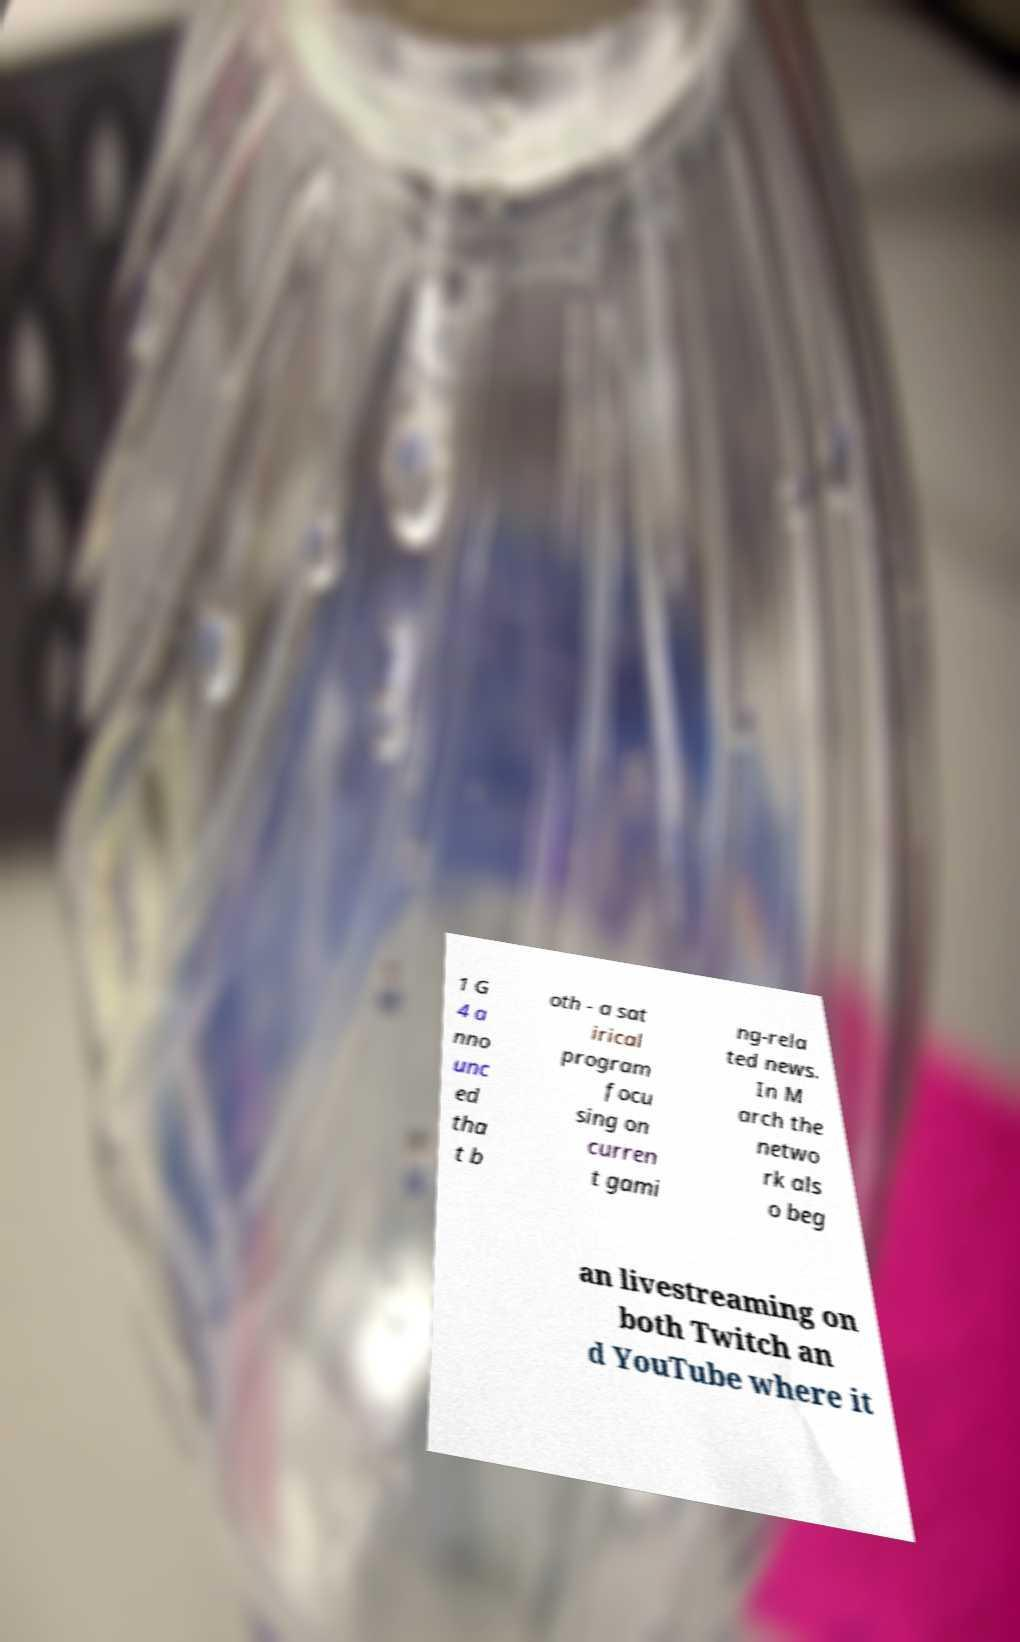There's text embedded in this image that I need extracted. Can you transcribe it verbatim? 1 G 4 a nno unc ed tha t b oth - a sat irical program focu sing on curren t gami ng-rela ted news. In M arch the netwo rk als o beg an livestreaming on both Twitch an d YouTube where it 